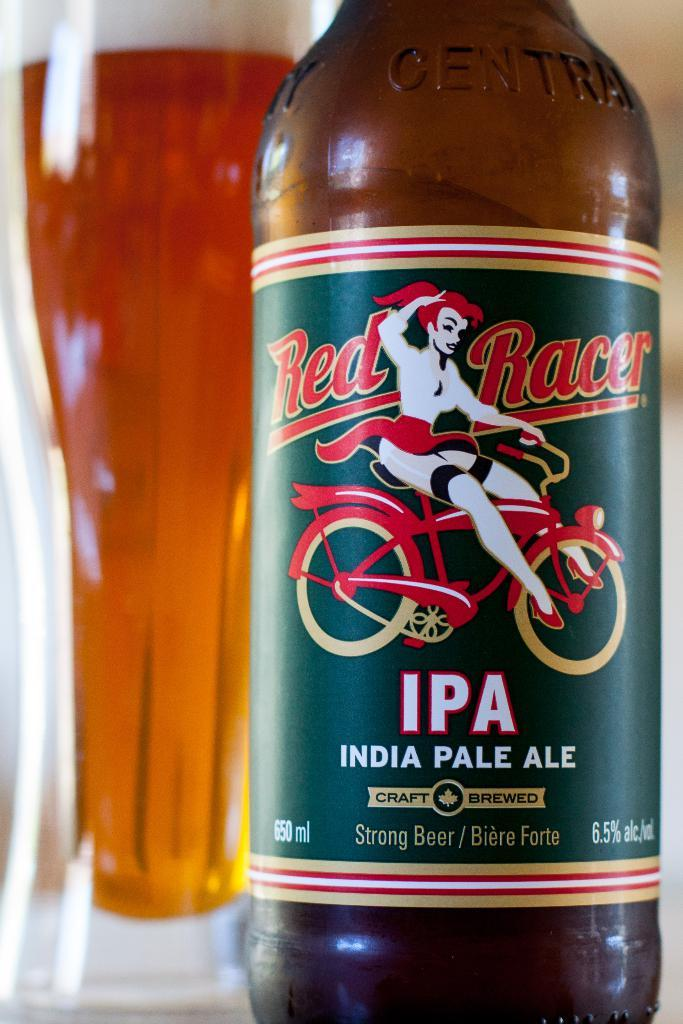<image>
Create a compact narrative representing the image presented. Bottle of India pale ale strong beet that contains alcohol 